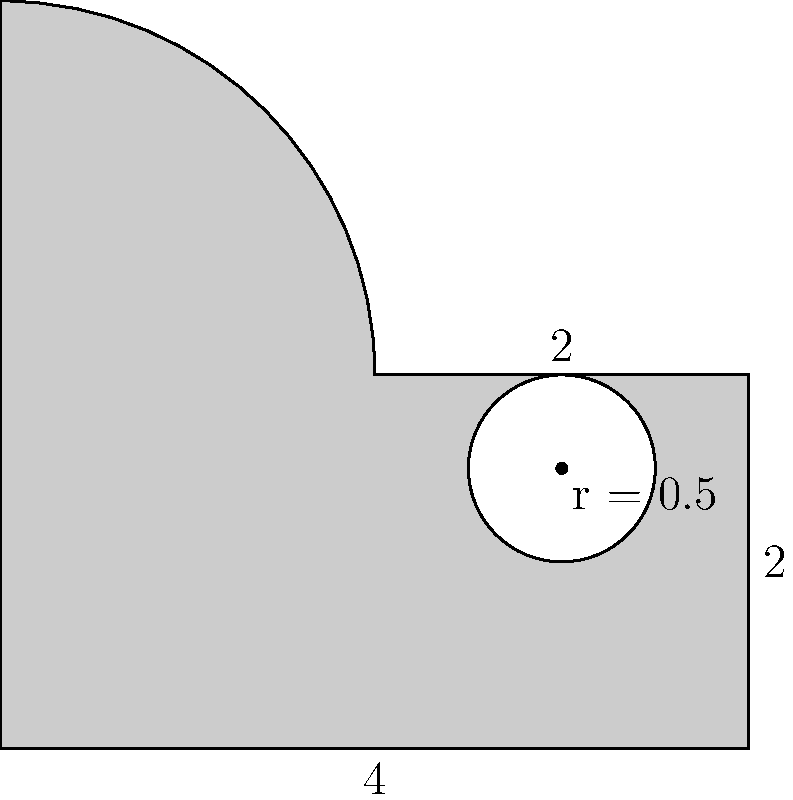As a creative thinker, you've been asked to estimate the area of a new logo design for a startup. The logo consists of a rectangle with a semicircle on top and a circular cutout. The base is 4 units wide, the rectangular portion is 2 units tall, and the circular cutout has a radius of 0.5 units. What is the total area of the logo? Let's break this down step-by-step:

1) First, let's calculate the area of the rectangle:
   $A_{rectangle} = 4 * 2 = 8$ square units

2) Next, the area of the semicircle on top:
   $A_{semicircle} = \frac{1}{2} * \pi r^2 = \frac{1}{2} * \pi * 2^2 = 2\pi$ square units

3) Now, we need to subtract the area of the circular cutout:
   $A_{cutout} = \pi r^2 = \pi * 0.5^2 = 0.25\pi$ square units

4) The total area is the sum of the rectangle and semicircle, minus the cutout:
   $A_{total} = A_{rectangle} + A_{semicircle} - A_{cutout}$
   $A_{total} = 8 + 2\pi - 0.25\pi$
   $A_{total} = 8 + 1.75\pi$

5) If we want a numerical value, we can approximate $\pi$ as 3.14159:
   $A_{total} \approx 8 + 1.75 * 3.14159 \approx 13.4978$ square units
Answer: $8 + 1.75\pi$ square units (or approximately 13.5 square units) 